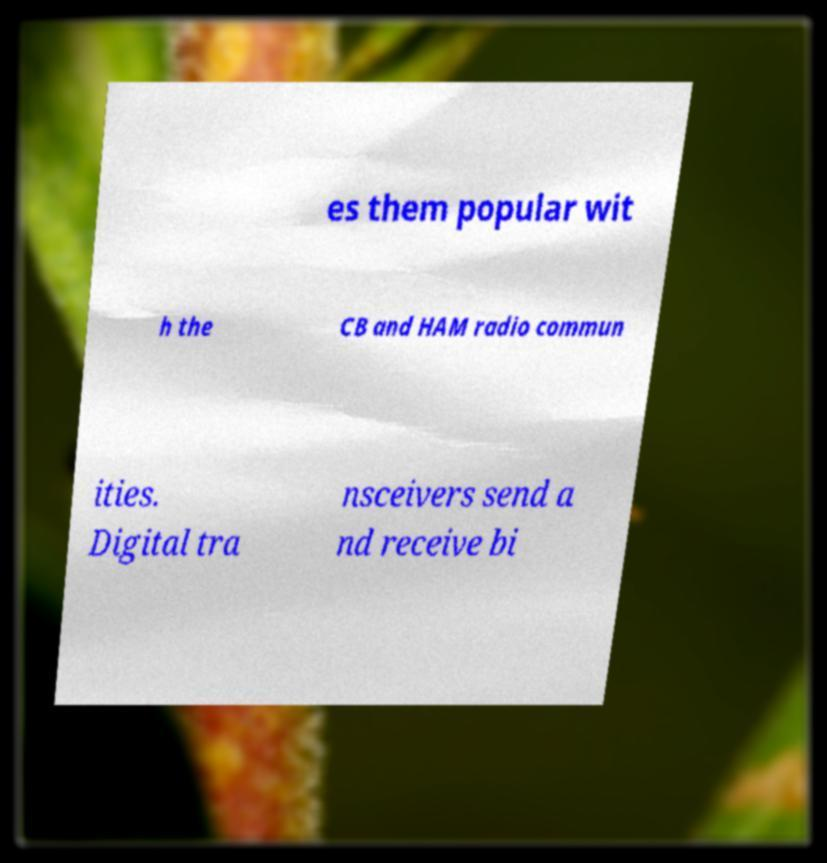What messages or text are displayed in this image? I need them in a readable, typed format. es them popular wit h the CB and HAM radio commun ities. Digital tra nsceivers send a nd receive bi 